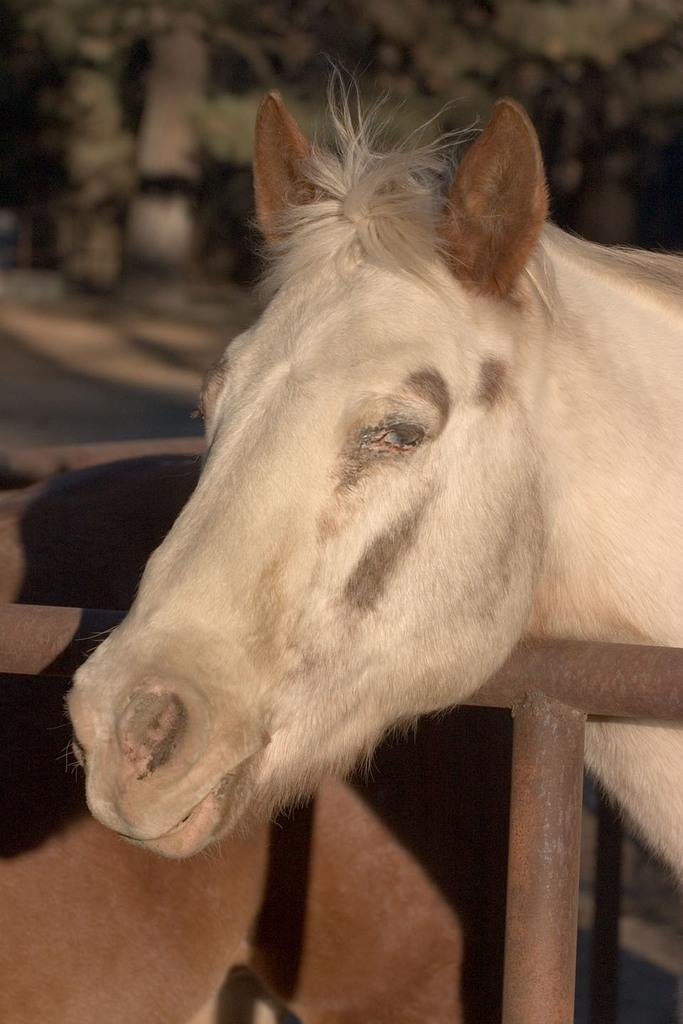What animal is the main subject of the image? There is a horse in the image. What part of the horse can be seen clearly? The horse's face is visible. What color is the horse? The horse is white in color. What is separating the horse from the photographer? The horse is standing behind fencing. How would you describe the background of the image? The background of the image is blurry. What type of dress is the horse wearing in the image? Horses do not wear dresses, so there is no dress present in the image. 